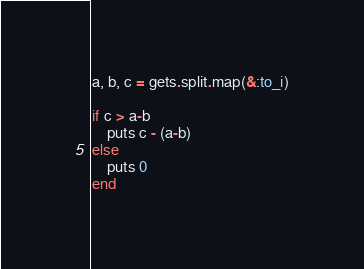Convert code to text. <code><loc_0><loc_0><loc_500><loc_500><_Ruby_>a, b, c = gets.split.map(&:to_i)

if c > a-b
    puts c - (a-b)
else
    puts 0
end</code> 